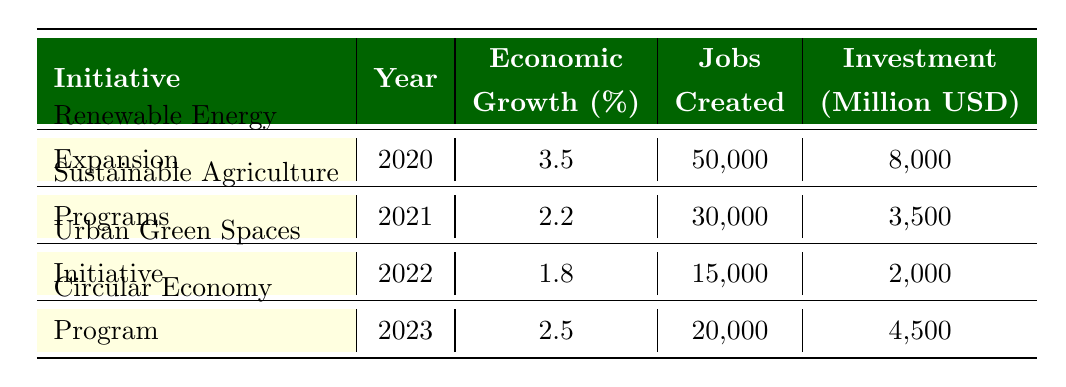What was the economic growth percentage for the Renewable Energy Expansion initiative in 2020? The table shows a specific row for the Renewable Energy Expansion initiative under the year 2020. The column for economic growth percentage lists the value as 3.5%.
Answer: 3.5% How many jobs were created by the Sustainable Agriculture Programs in 2021? The table indicates the Sustainable Agriculture Programs for the year 2021, with the jobs created being listed in the corresponding column as 30,000.
Answer: 30,000 What is the total investment amount for Urban Green Spaces Initiative and Circular Economy Program from 2022 to 2023? The investment amounts listed in the table for these initiatives are 2,000 million USD (Urban Green Spaces Initiative, 2022) and 4,500 million USD (Circular Economy Program, 2023). Adding these gives 2,000 + 4,500 = 6,500 million USD.
Answer: 6,500 million USD Is the economic growth percentage for the Circular Economy Program higher than the Urban Green Spaces Initiative in 2023? The table lists the economic growth percentage for the Circular Economy Program as 2.5% and for the Urban Green Spaces Initiative as 1.8%. Since 2.5% is greater than 1.8%, the answer is yes.
Answer: Yes What is the average economic growth percentage across all initiatives from 2020 to 2023? The economic growth percentages from the table are 3.5%, 2.2%, 1.8%, and 2.5%. To find the average, add these values (3.5 + 2.2 + 1.8 + 2.5 = 10.0) and divide by the number of initiatives (4), resulting in 10.0 / 4 = 2.5%.
Answer: 2.5% 